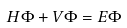<formula> <loc_0><loc_0><loc_500><loc_500>H \Phi + V \Phi = E \Phi</formula> 